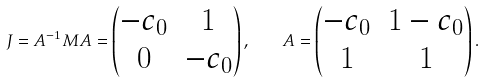Convert formula to latex. <formula><loc_0><loc_0><loc_500><loc_500>J = A ^ { - 1 } M A = \begin{pmatrix} - c _ { 0 } & 1 \\ 0 & - c _ { 0 } \end{pmatrix} , \quad A = \begin{pmatrix} - c _ { 0 } & 1 - c _ { 0 } \\ 1 & 1 \end{pmatrix} .</formula> 